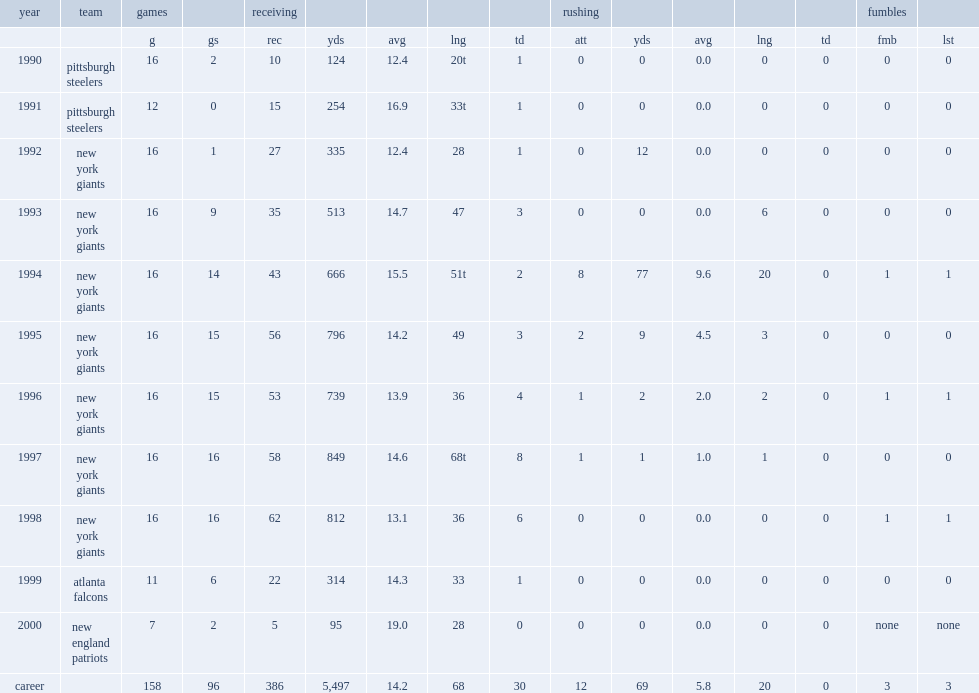Which year did chris calloway perform the best? 1997.0. 